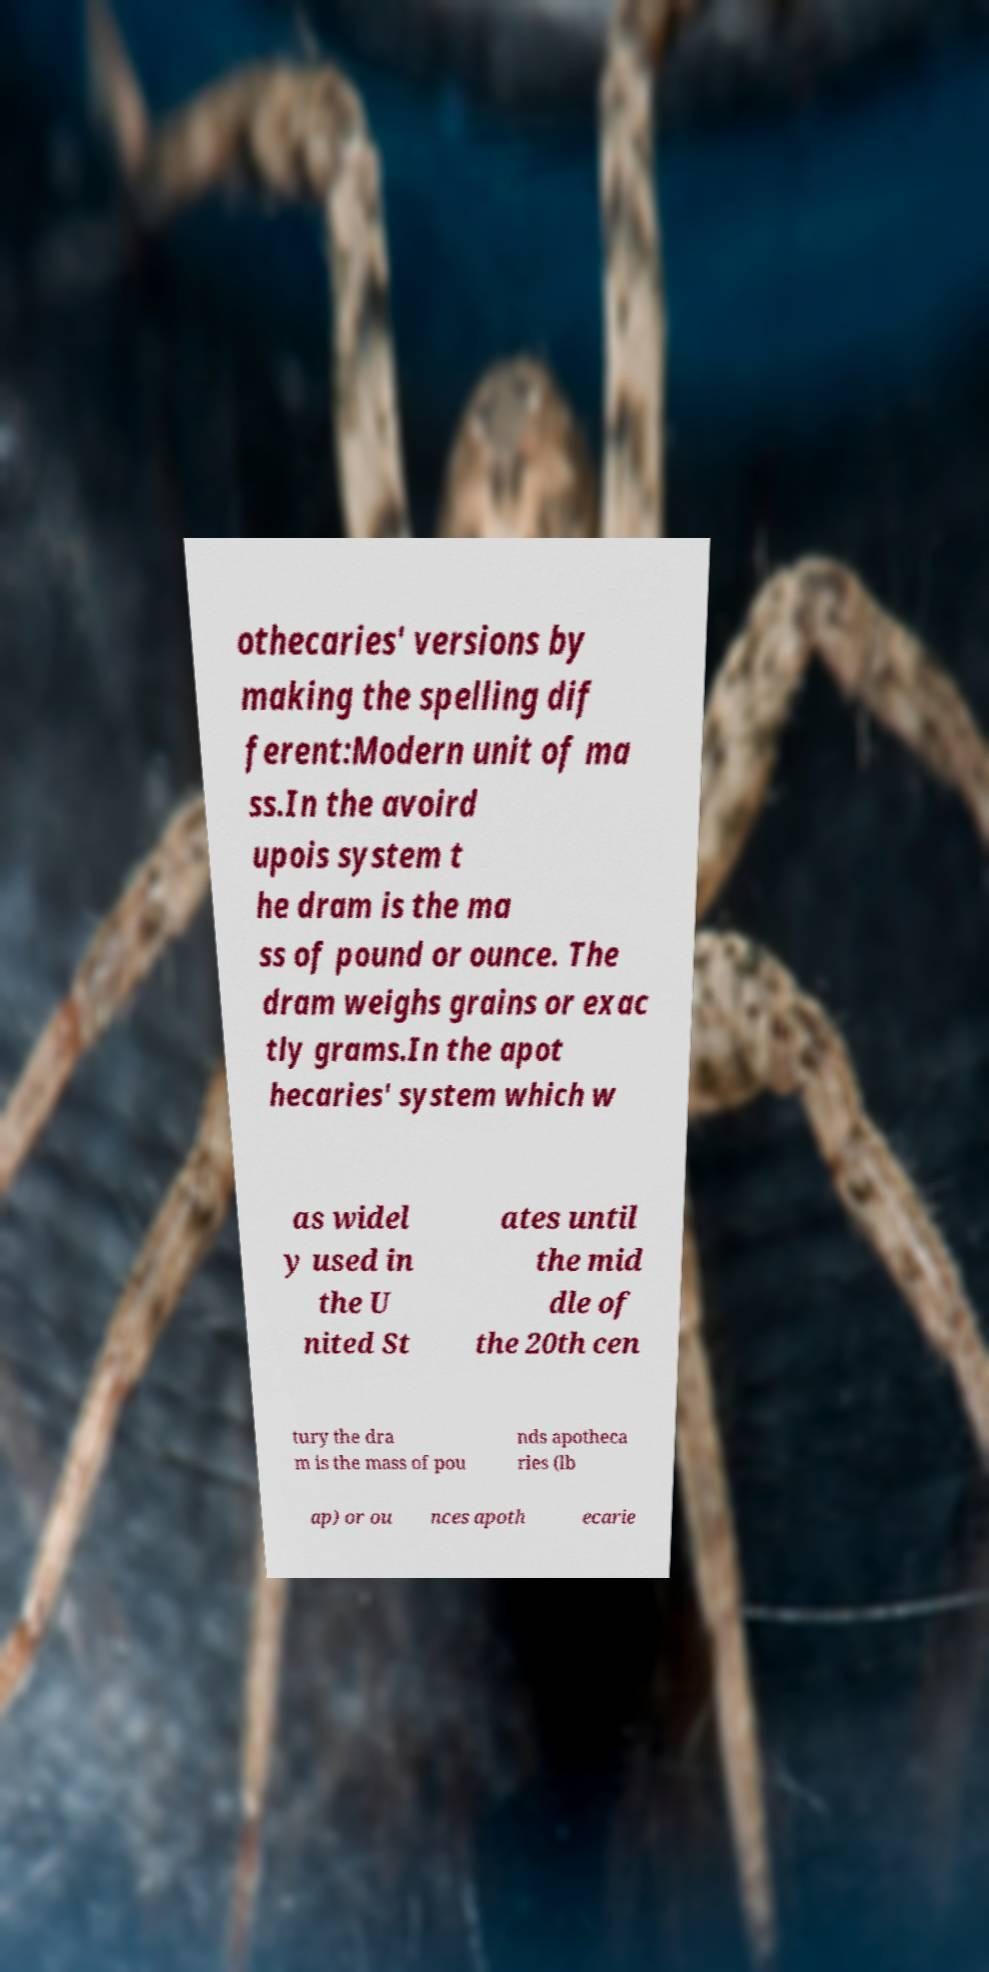Could you assist in decoding the text presented in this image and type it out clearly? othecaries' versions by making the spelling dif ferent:Modern unit of ma ss.In the avoird upois system t he dram is the ma ss of pound or ounce. The dram weighs grains or exac tly grams.In the apot hecaries' system which w as widel y used in the U nited St ates until the mid dle of the 20th cen tury the dra m is the mass of pou nds apotheca ries (lb ap) or ou nces apoth ecarie 